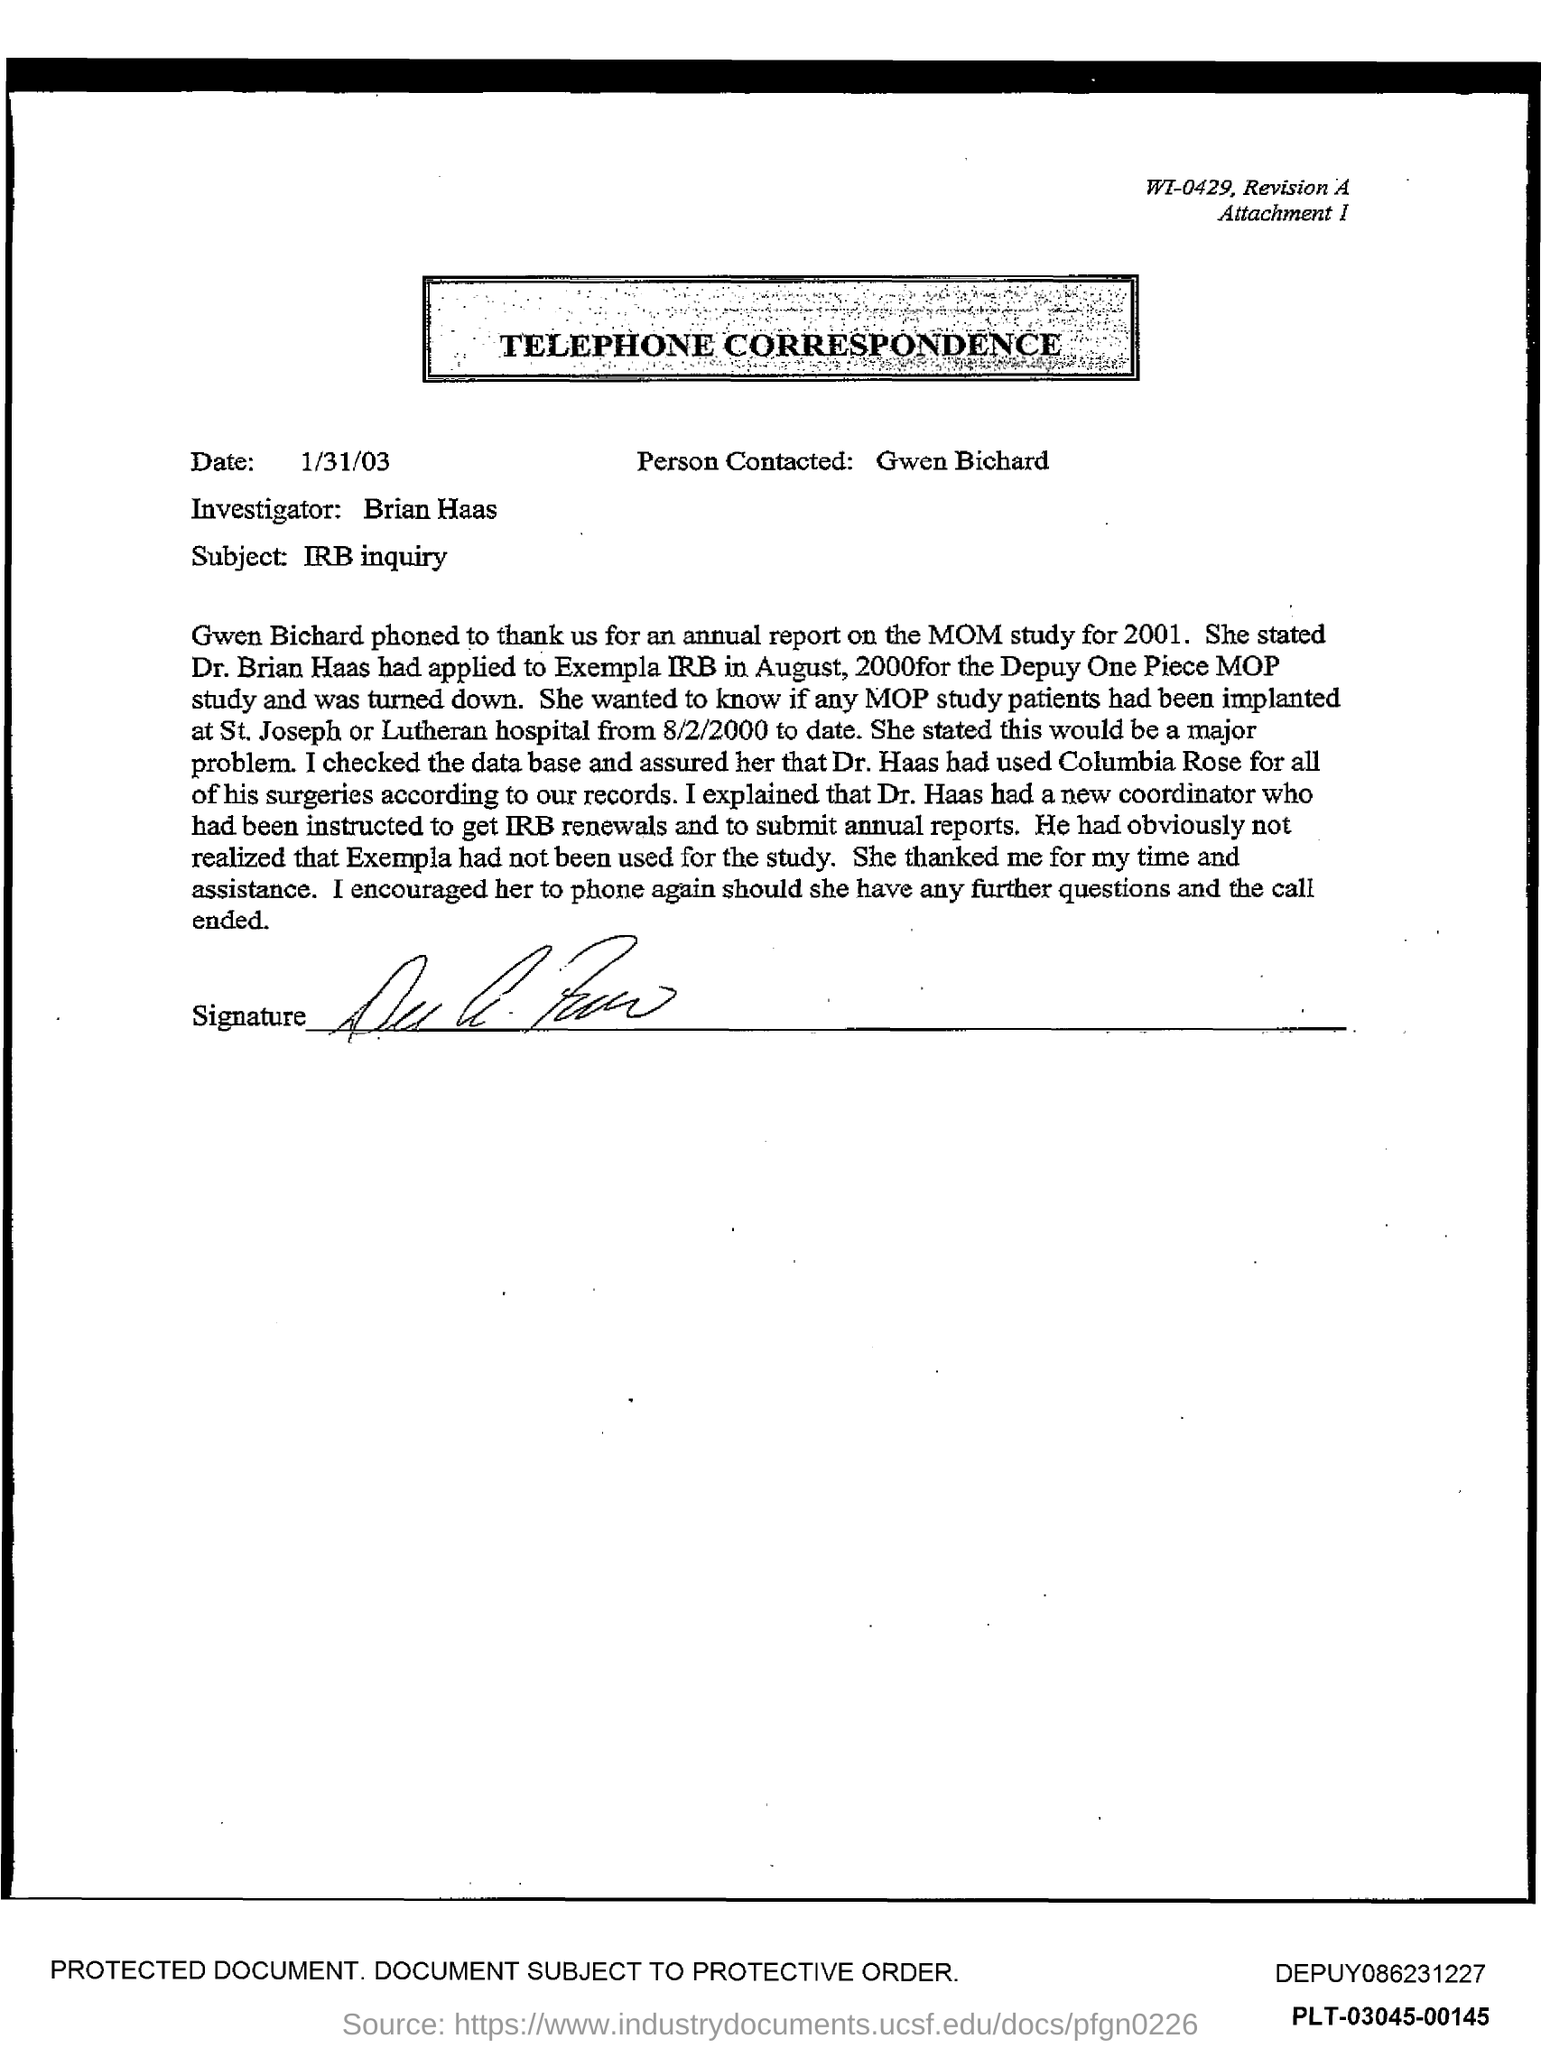What type of communication is this?
Give a very brief answer. TELEPHONE CORRESPONDENCE. Who is the person contacted?
Provide a short and direct response. Gwen Bichard. Who is the investigator as per the correspondence?
Ensure brevity in your answer.  Brian Haas. What is the subject of the telephone correspondence?
Your answer should be compact. IRB inquiry. What is the date of the telephone correspondence?
Offer a very short reply. 1/31/03. 